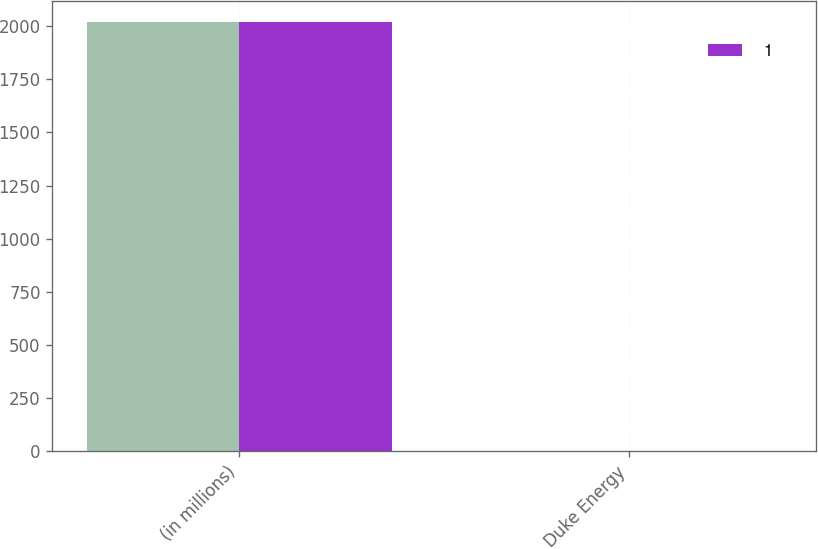Convert chart. <chart><loc_0><loc_0><loc_500><loc_500><stacked_bar_chart><ecel><fcel>(in millions)<fcel>Duke Energy<nl><fcel>nan<fcel>2018<fcel>3<nl><fcel>1<fcel>2019<fcel>2<nl></chart> 